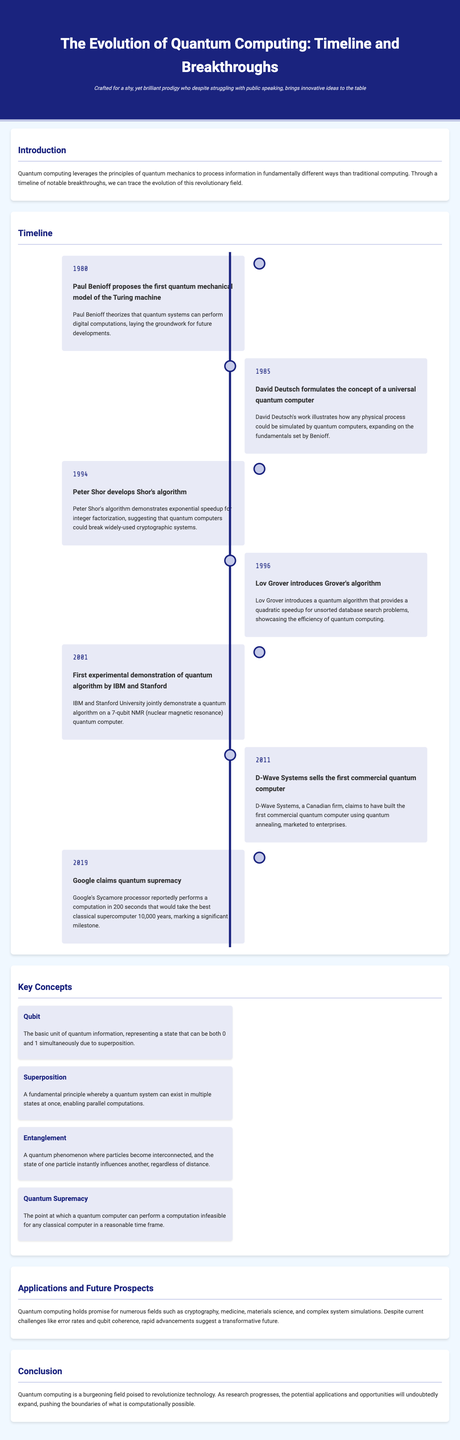What year did Paul Benioff propose the first quantum mechanical model of the Turing machine? The document states that Paul Benioff proposed the first quantum mechanical model of the Turing machine in 1980.
Answer: 1980 Who developed Shor's algorithm? According to the timeline, Shor's algorithm was developed by Peter Shor in 1994.
Answer: Peter Shor What major event occurred in 2019 related to quantum computing? The document mentions that Google claimed quantum supremacy in 2019.
Answer: Claim of quantum supremacy What is a qubit? The document defines a qubit as the basic unit of quantum information, representing a state that can be both 0 and 1 simultaneously due to superposition.
Answer: Basic unit of quantum information What does the term "quantum supremacy" refer to? Quantum supremacy is defined in the document as the point at which a quantum computer can perform a computation infeasible for any classical computer in a reasonable time frame.
Answer: Computation infeasible for classical computers How many years passed between the proposal of the universal quantum computer and the development of Shor's algorithm? The proposal of the universal quantum computer was in 1985, and Shor's algorithm was developed in 1994, so 9 years passed between these events.
Answer: 9 years What major development occurred in 2011 regarding quantum computing? The document states that D-Wave Systems sold the first commercial quantum computer in 2011.
Answer: First commercial quantum computer Which algorithm introduced a quadratic speedup for unsorted database search problems? The document indicates that Grover's algorithm introduced a quadratic speedup for unsorted database search problems in 1996.
Answer: Grover's algorithm What field is mentioned as a potential application of quantum computing? The document lists cryptography, medicine, materials science, and complex system simulations as potential application fields for quantum computing.
Answer: Cryptography 